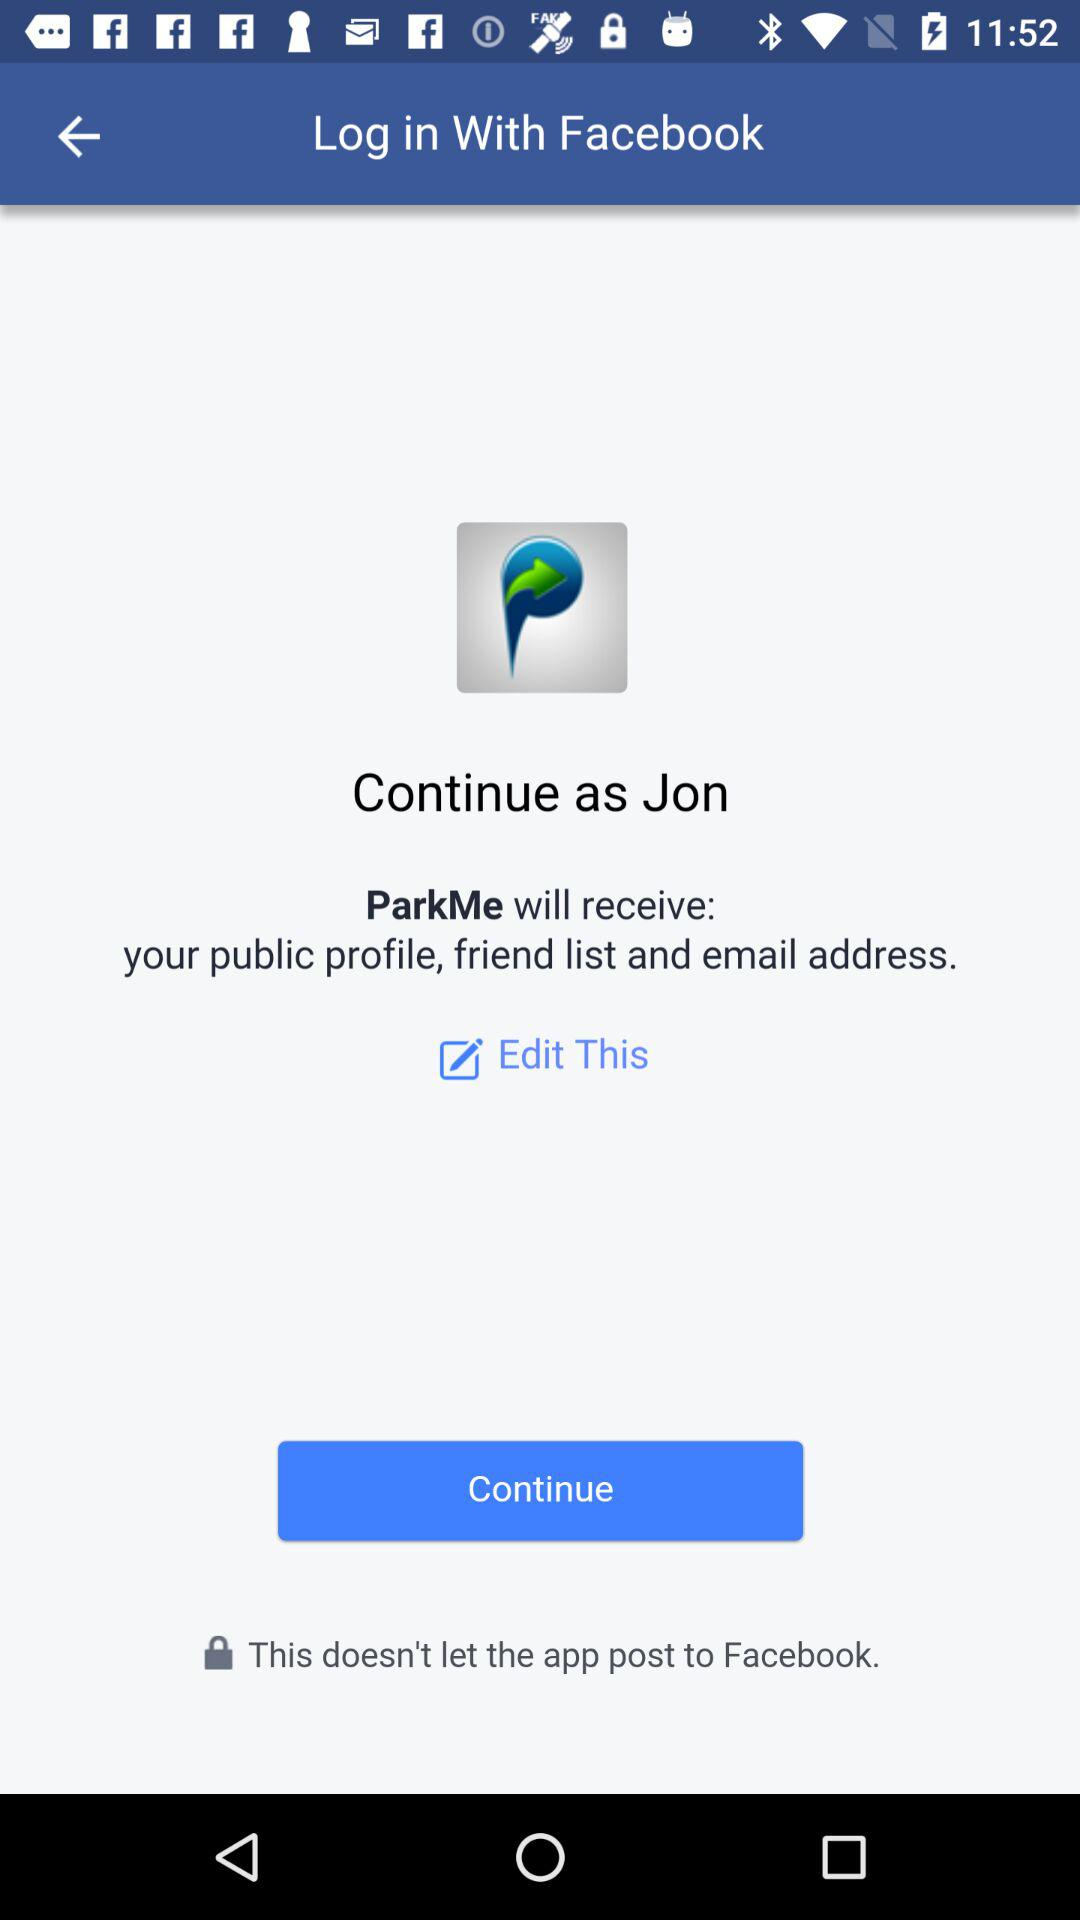Who will receive the public profile and email address? The application that will receive the public profile and email address is "ParkMe". 